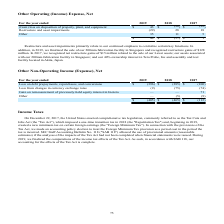According to Micron Technology's financial document, In 2017, what is the net restructure gains of $15 million related to? the sale of our Lexar assets; our assets associated with our 200mm fabrication facility in Singapore; and our 40% ownership interest in Tera Probe, Inc and assembly and test facility located in Akita, Japan. The document states: "d net restructure gains of $15 million related to the sale of our Lexar assets; our assets associated with our 200mm fabrication facility in Singapore..." Also, How much restructure gains did the company recognize in 2019? According to the financial document, $128 million. The relevant text states: "y in Singapore and recognized restructure gains of $128 million. In 2017, we recognized net restructure gains of $15 million related to the sale of our Lexar asset..." Also, What is the net other operating (income) expense for restructure and asset impairments in 2017? According to the financial document, 18 (in millions). The relevant text states: "For the year ended 2019 2018 2017..." Also, can you calculate: What is the percentage change of other operating (income) expenses for restructure and asset impairments between 2017 and 2018? To answer this question, I need to perform calculations using the financial data. The calculation is: (28-18)/18 , which equals 55.56 (percentage). This is based on the information: "Restructure and asset impairments (29) 28 18 Restructure and asset impairments (29) 28 18..." The key data points involved are: 18, 28. Also, can you calculate: What is the ratio of other operating expenses in 2019 to 2017? Based on the calculation: 35/5 , the result is 7. This is based on the information: "Other 35 11 5 Other 35 11 5..." The key data points involved are: 35, 5. Also, can you calculate: What is the difference between total net other operating (income) expenses in 2017 and 2019? Based on the calculation: $49-$1 , the result is 48 (in millions). This is based on the information: "$ 49 $ (57) $ 1 For the year ended 2019 2018 2017..." The key data points involved are: 1, 49. 